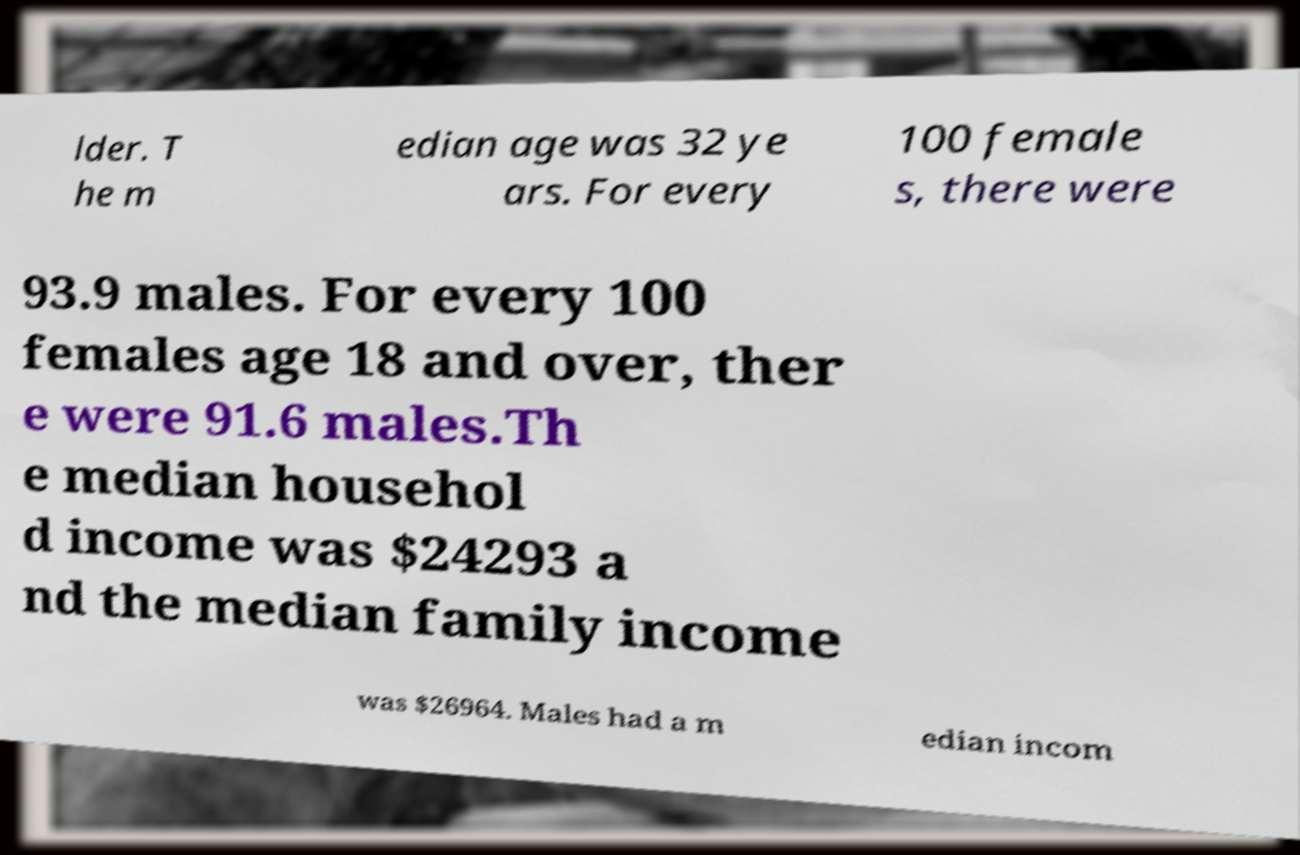Please identify and transcribe the text found in this image. lder. T he m edian age was 32 ye ars. For every 100 female s, there were 93.9 males. For every 100 females age 18 and over, ther e were 91.6 males.Th e median househol d income was $24293 a nd the median family income was $26964. Males had a m edian incom 